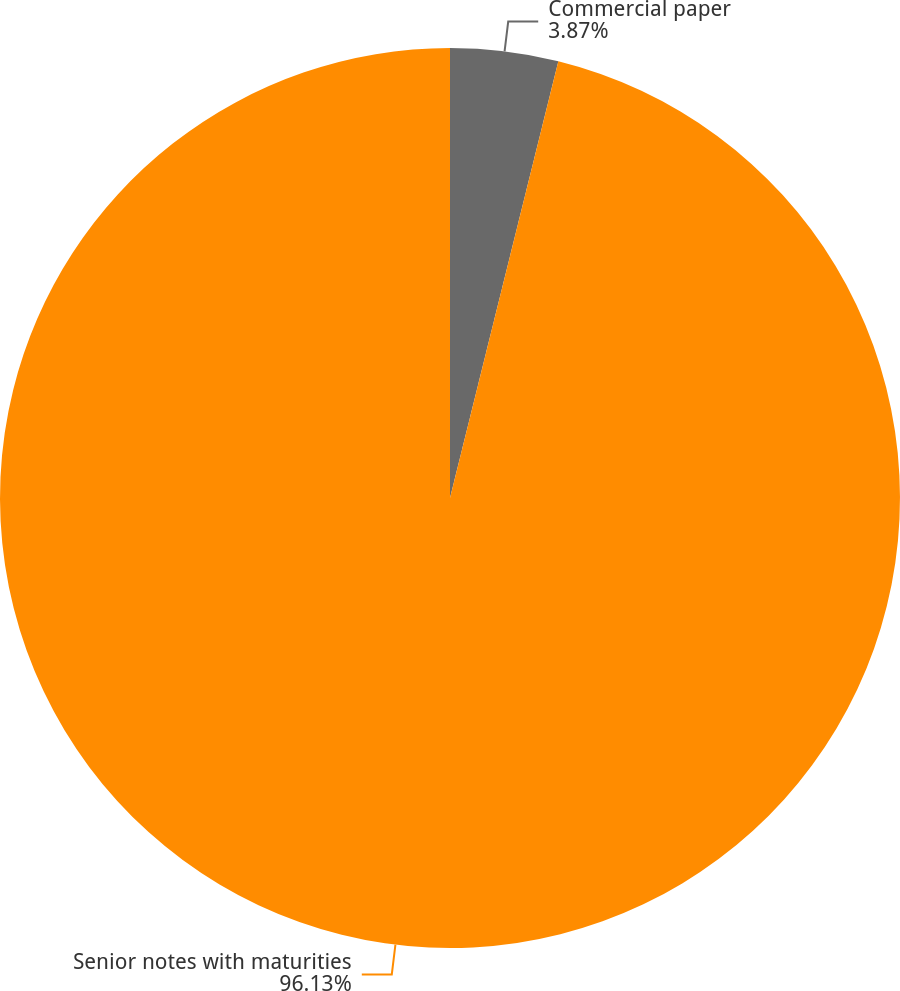<chart> <loc_0><loc_0><loc_500><loc_500><pie_chart><fcel>Commercial paper<fcel>Senior notes with maturities<nl><fcel>3.87%<fcel>96.13%<nl></chart> 